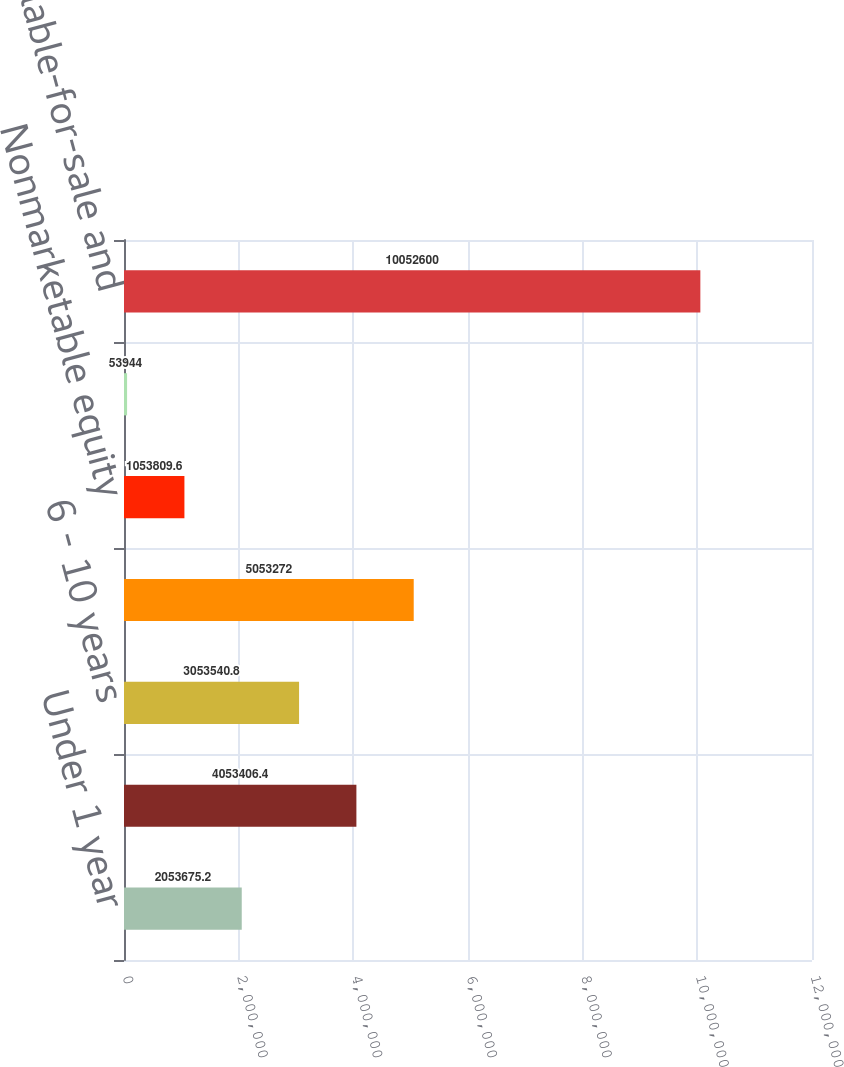Convert chart to OTSL. <chart><loc_0><loc_0><loc_500><loc_500><bar_chart><fcel>Under 1 year<fcel>1 - 5 years<fcel>6 - 10 years<fcel>Over 10 years<fcel>Nonmarketable equity<fcel>Marketable equity securities<fcel>Total available-for-sale and<nl><fcel>2.05368e+06<fcel>4.05341e+06<fcel>3.05354e+06<fcel>5.05327e+06<fcel>1.05381e+06<fcel>53944<fcel>1.00526e+07<nl></chart> 